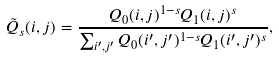Convert formula to latex. <formula><loc_0><loc_0><loc_500><loc_500>\tilde { Q } _ { s } ( i , j ) = \frac { Q _ { 0 } ( i , j ) ^ { 1 - s } Q _ { 1 } ( i , j ) ^ { s } } { \sum _ { i ^ { \prime } , j ^ { \prime } } Q _ { 0 } ( i ^ { \prime } , j ^ { \prime } ) ^ { 1 - s } Q _ { 1 } ( i ^ { \prime } , j ^ { \prime } ) ^ { s } } ,</formula> 